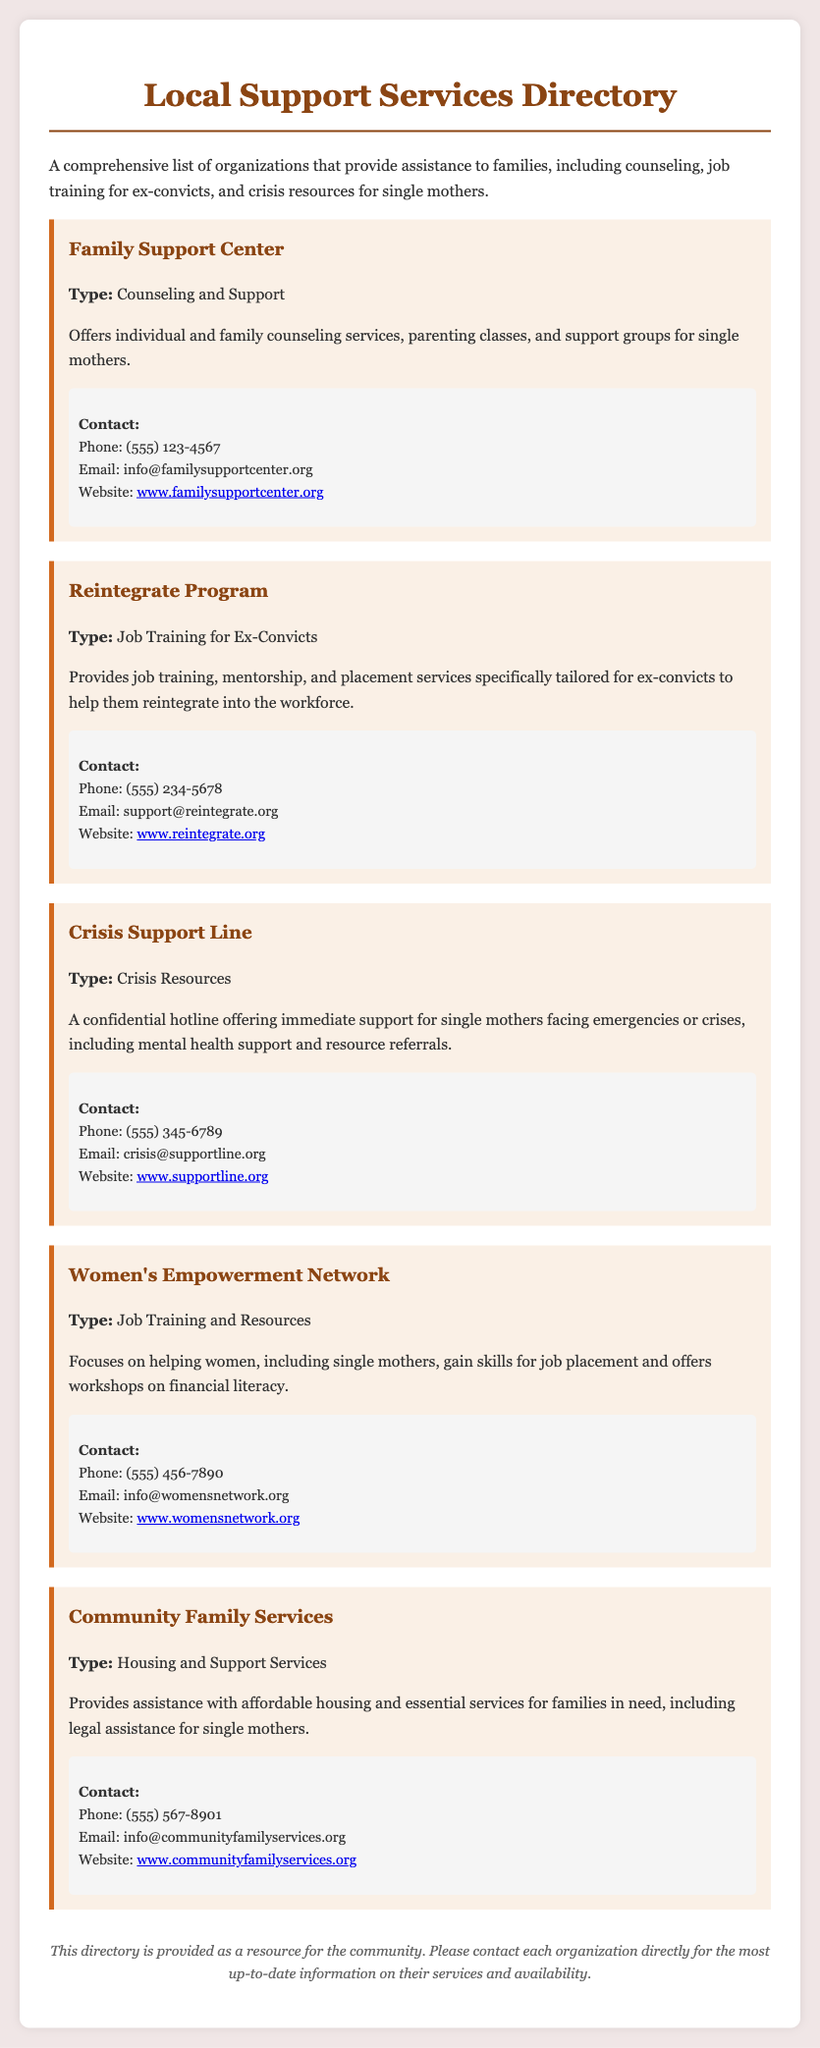What is the name of the counseling service? The document lists the "Family Support Center" as the counseling service.
Answer: Family Support Center What type of services does the Reintegrate Program provide? The Reintegrate Program offers job training for ex-convicts.
Answer: Job Training for Ex-Convicts What is the contact email for the Crisis Support Line? The email address listed for the Crisis Support Line is crisis@supportline.org.
Answer: crisis@supportline.org How many contact numbers are provided in the directory? There are five different contact numbers provided for the services listed.
Answer: 5 Which organization focuses on financial literacy for women? The Women's Empowerment Network focuses on financial literacy.
Answer: Women's Empowerment Network What type of support does Community Family Services offer for single mothers? Community Family Services provides legal assistance for single mothers.
Answer: Legal assistance Which service is specifically tailored for ex-convicts? The service specifically tailored for ex-convicts is the Reintegrate Program.
Answer: Reintegrate Program What is the main purpose of the document? The main purpose of the document is to provide a directory of local support services for families.
Answer: Directory of local support services for families 